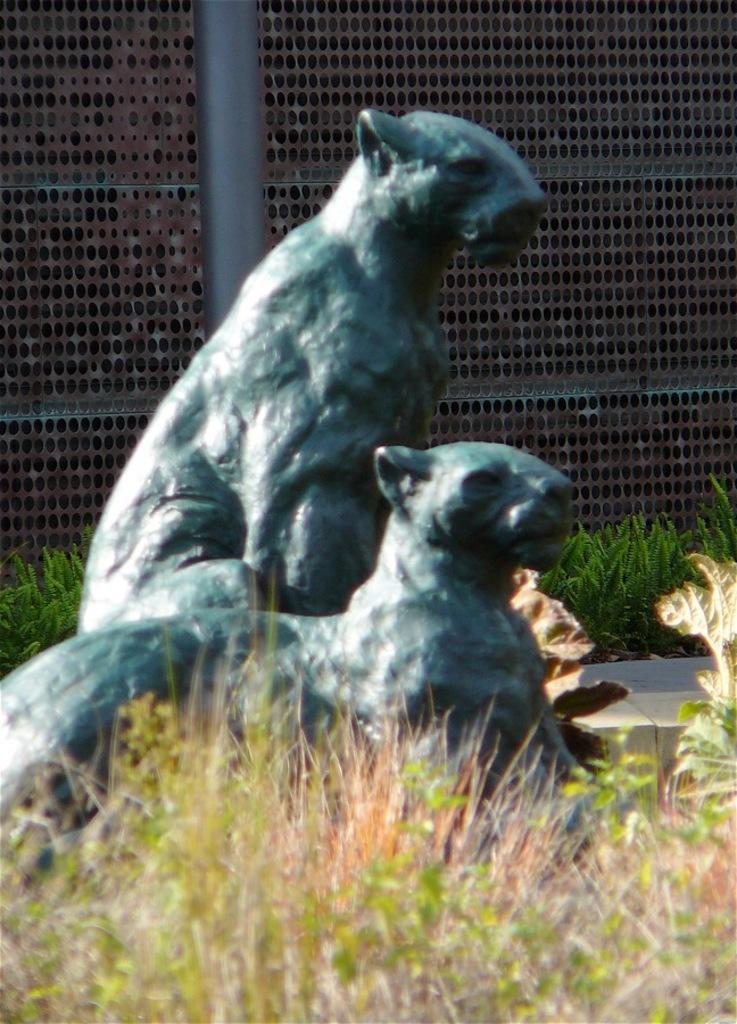What type of vegetation is present in the image? There is grass in the image. What type of objects can be seen in the image? There are statues in the image. What can be seen in the background of the image? There is a pole, plants, and a mesh in the background of the image. What type of utensil is being used to light the flame in the image? There is no utensil or flame present in the image. 